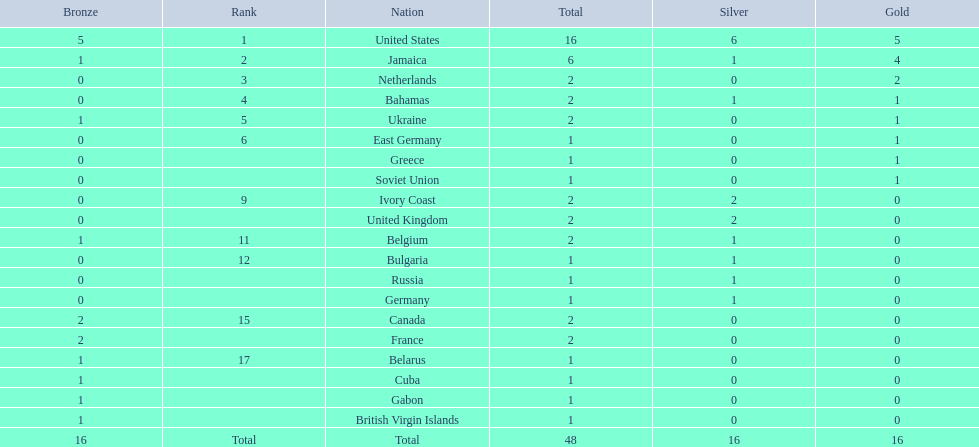Which countries participated? United States, Jamaica, Netherlands, Bahamas, Ukraine, East Germany, Greece, Soviet Union, Ivory Coast, United Kingdom, Belgium, Bulgaria, Russia, Germany, Canada, France, Belarus, Cuba, Gabon, British Virgin Islands. How many gold medals were won by each? 5, 4, 2, 1, 1, 1, 1, 1, 0, 0, 0, 0, 0, 0, 0, 0, 0, 0, 0, 0. And which country won the most? United States. 